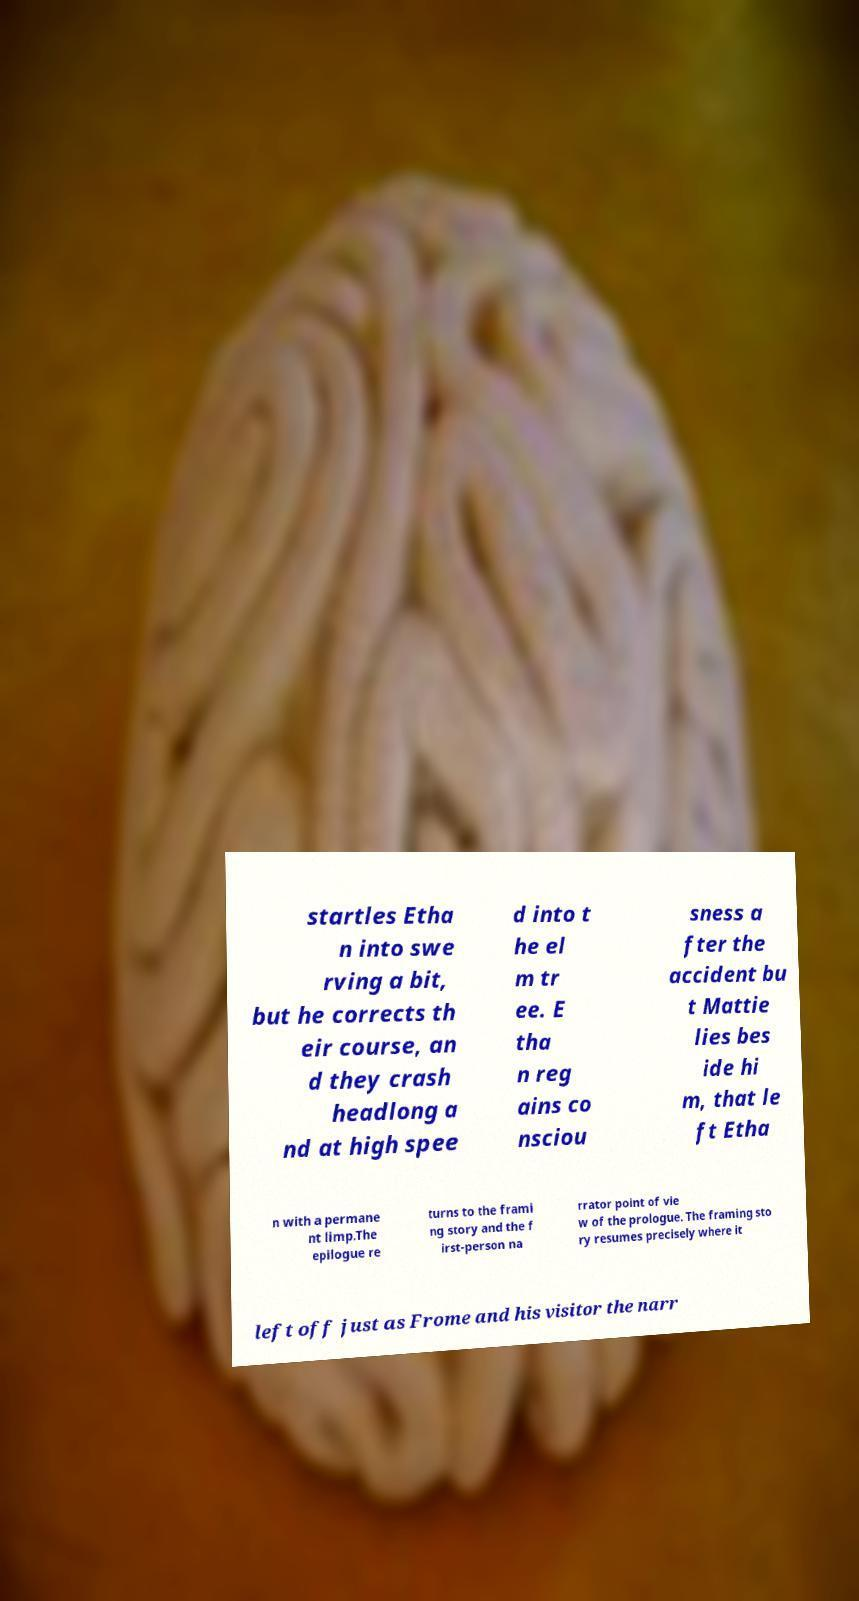I need the written content from this picture converted into text. Can you do that? startles Etha n into swe rving a bit, but he corrects th eir course, an d they crash headlong a nd at high spee d into t he el m tr ee. E tha n reg ains co nsciou sness a fter the accident bu t Mattie lies bes ide hi m, that le ft Etha n with a permane nt limp.The epilogue re turns to the frami ng story and the f irst-person na rrator point of vie w of the prologue. The framing sto ry resumes precisely where it left off just as Frome and his visitor the narr 